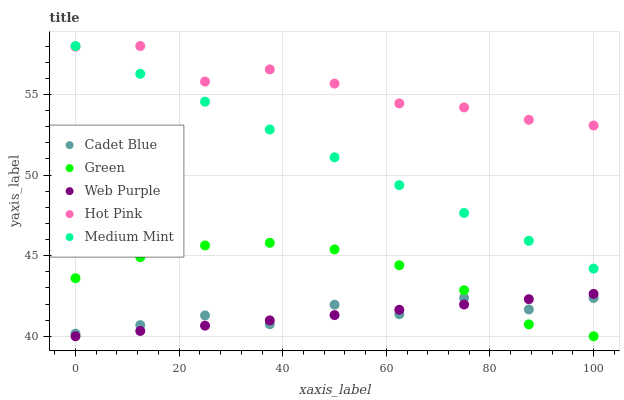Does Web Purple have the minimum area under the curve?
Answer yes or no. Yes. Does Hot Pink have the maximum area under the curve?
Answer yes or no. Yes. Does Cadet Blue have the minimum area under the curve?
Answer yes or no. No. Does Cadet Blue have the maximum area under the curve?
Answer yes or no. No. Is Web Purple the smoothest?
Answer yes or no. Yes. Is Cadet Blue the roughest?
Answer yes or no. Yes. Is Cadet Blue the smoothest?
Answer yes or no. No. Is Web Purple the roughest?
Answer yes or no. No. Does Web Purple have the lowest value?
Answer yes or no. Yes. Does Cadet Blue have the lowest value?
Answer yes or no. No. Does Hot Pink have the highest value?
Answer yes or no. Yes. Does Web Purple have the highest value?
Answer yes or no. No. Is Green less than Medium Mint?
Answer yes or no. Yes. Is Hot Pink greater than Green?
Answer yes or no. Yes. Does Green intersect Web Purple?
Answer yes or no. Yes. Is Green less than Web Purple?
Answer yes or no. No. Is Green greater than Web Purple?
Answer yes or no. No. Does Green intersect Medium Mint?
Answer yes or no. No. 